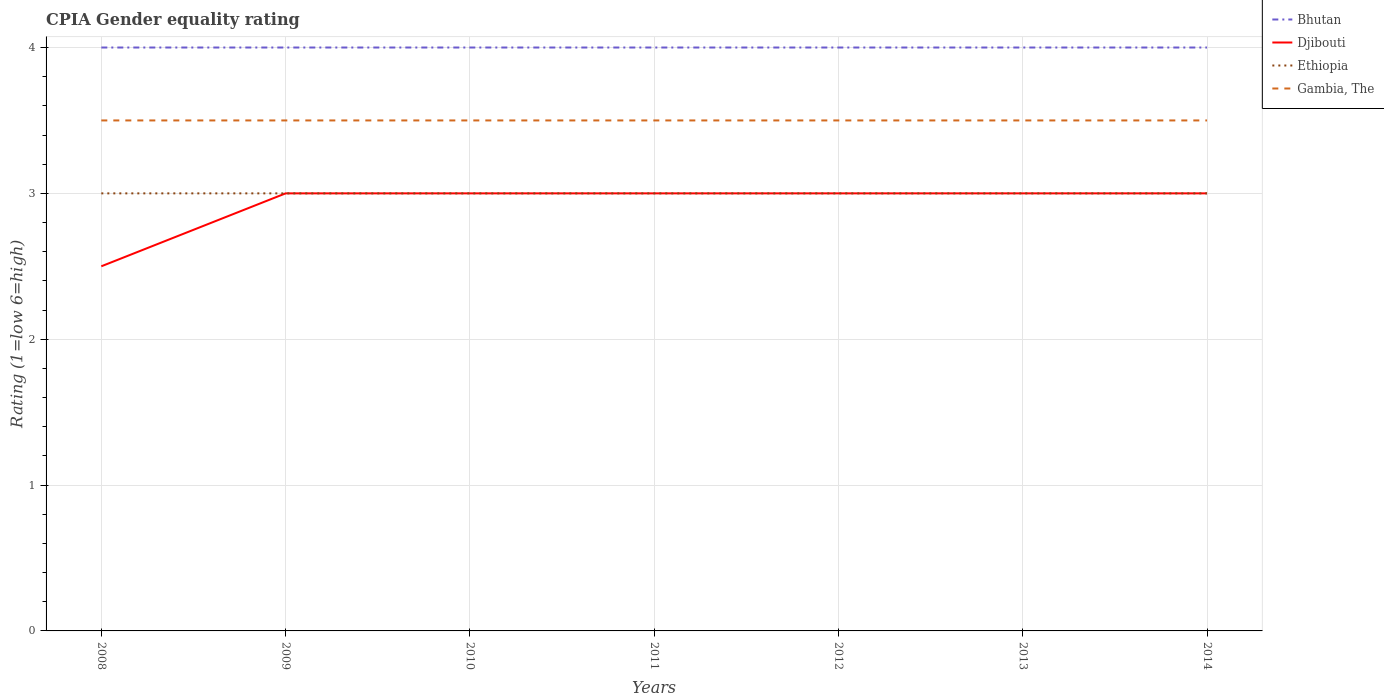How many different coloured lines are there?
Offer a terse response. 4. In which year was the CPIA rating in Bhutan maximum?
Offer a terse response. 2008. What is the difference between two consecutive major ticks on the Y-axis?
Ensure brevity in your answer.  1. Are the values on the major ticks of Y-axis written in scientific E-notation?
Offer a very short reply. No. Where does the legend appear in the graph?
Offer a terse response. Top right. How many legend labels are there?
Offer a very short reply. 4. What is the title of the graph?
Your answer should be compact. CPIA Gender equality rating. What is the label or title of the X-axis?
Your answer should be very brief. Years. What is the label or title of the Y-axis?
Make the answer very short. Rating (1=low 6=high). What is the Rating (1=low 6=high) of Bhutan in 2008?
Give a very brief answer. 4. What is the Rating (1=low 6=high) of Bhutan in 2009?
Offer a very short reply. 4. What is the Rating (1=low 6=high) in Ethiopia in 2009?
Make the answer very short. 3. What is the Rating (1=low 6=high) in Bhutan in 2010?
Your answer should be very brief. 4. What is the Rating (1=low 6=high) in Bhutan in 2011?
Provide a succinct answer. 4. What is the Rating (1=low 6=high) of Djibouti in 2011?
Provide a short and direct response. 3. What is the Rating (1=low 6=high) in Ethiopia in 2011?
Ensure brevity in your answer.  3. What is the Rating (1=low 6=high) in Djibouti in 2013?
Offer a terse response. 3. What is the Rating (1=low 6=high) in Ethiopia in 2013?
Your answer should be very brief. 3. What is the Rating (1=low 6=high) of Gambia, The in 2013?
Provide a short and direct response. 3.5. What is the Rating (1=low 6=high) of Bhutan in 2014?
Your answer should be very brief. 4. What is the Rating (1=low 6=high) in Ethiopia in 2014?
Provide a succinct answer. 3. Across all years, what is the maximum Rating (1=low 6=high) of Gambia, The?
Provide a short and direct response. 3.5. Across all years, what is the minimum Rating (1=low 6=high) in Bhutan?
Offer a very short reply. 4. Across all years, what is the minimum Rating (1=low 6=high) of Djibouti?
Your response must be concise. 2.5. What is the total Rating (1=low 6=high) of Bhutan in the graph?
Your answer should be compact. 28. What is the total Rating (1=low 6=high) of Djibouti in the graph?
Ensure brevity in your answer.  20.5. What is the total Rating (1=low 6=high) of Ethiopia in the graph?
Your answer should be very brief. 21. What is the total Rating (1=low 6=high) in Gambia, The in the graph?
Your answer should be compact. 24.5. What is the difference between the Rating (1=low 6=high) in Djibouti in 2008 and that in 2009?
Your response must be concise. -0.5. What is the difference between the Rating (1=low 6=high) of Ethiopia in 2008 and that in 2009?
Provide a succinct answer. 0. What is the difference between the Rating (1=low 6=high) of Bhutan in 2008 and that in 2010?
Ensure brevity in your answer.  0. What is the difference between the Rating (1=low 6=high) of Djibouti in 2008 and that in 2010?
Provide a short and direct response. -0.5. What is the difference between the Rating (1=low 6=high) in Gambia, The in 2008 and that in 2010?
Give a very brief answer. 0. What is the difference between the Rating (1=low 6=high) of Bhutan in 2008 and that in 2011?
Keep it short and to the point. 0. What is the difference between the Rating (1=low 6=high) of Djibouti in 2008 and that in 2011?
Keep it short and to the point. -0.5. What is the difference between the Rating (1=low 6=high) of Ethiopia in 2008 and that in 2011?
Make the answer very short. 0. What is the difference between the Rating (1=low 6=high) of Gambia, The in 2008 and that in 2011?
Offer a very short reply. 0. What is the difference between the Rating (1=low 6=high) of Ethiopia in 2008 and that in 2012?
Keep it short and to the point. 0. What is the difference between the Rating (1=low 6=high) of Gambia, The in 2008 and that in 2012?
Your answer should be compact. 0. What is the difference between the Rating (1=low 6=high) in Djibouti in 2008 and that in 2013?
Offer a terse response. -0.5. What is the difference between the Rating (1=low 6=high) of Ethiopia in 2008 and that in 2013?
Provide a short and direct response. 0. What is the difference between the Rating (1=low 6=high) of Bhutan in 2008 and that in 2014?
Provide a succinct answer. 0. What is the difference between the Rating (1=low 6=high) in Gambia, The in 2008 and that in 2014?
Ensure brevity in your answer.  0. What is the difference between the Rating (1=low 6=high) of Bhutan in 2009 and that in 2010?
Provide a succinct answer. 0. What is the difference between the Rating (1=low 6=high) of Ethiopia in 2009 and that in 2010?
Keep it short and to the point. 0. What is the difference between the Rating (1=low 6=high) in Gambia, The in 2009 and that in 2010?
Keep it short and to the point. 0. What is the difference between the Rating (1=low 6=high) in Bhutan in 2009 and that in 2011?
Provide a succinct answer. 0. What is the difference between the Rating (1=low 6=high) of Gambia, The in 2009 and that in 2011?
Make the answer very short. 0. What is the difference between the Rating (1=low 6=high) in Bhutan in 2009 and that in 2012?
Your answer should be compact. 0. What is the difference between the Rating (1=low 6=high) of Bhutan in 2009 and that in 2013?
Give a very brief answer. 0. What is the difference between the Rating (1=low 6=high) of Djibouti in 2009 and that in 2013?
Provide a succinct answer. 0. What is the difference between the Rating (1=low 6=high) in Gambia, The in 2009 and that in 2013?
Your answer should be very brief. 0. What is the difference between the Rating (1=low 6=high) of Ethiopia in 2009 and that in 2014?
Provide a succinct answer. 0. What is the difference between the Rating (1=low 6=high) in Djibouti in 2010 and that in 2011?
Provide a short and direct response. 0. What is the difference between the Rating (1=low 6=high) of Ethiopia in 2010 and that in 2011?
Make the answer very short. 0. What is the difference between the Rating (1=low 6=high) of Gambia, The in 2010 and that in 2011?
Provide a succinct answer. 0. What is the difference between the Rating (1=low 6=high) of Djibouti in 2010 and that in 2012?
Your answer should be compact. 0. What is the difference between the Rating (1=low 6=high) of Ethiopia in 2010 and that in 2012?
Your answer should be compact. 0. What is the difference between the Rating (1=low 6=high) in Gambia, The in 2010 and that in 2012?
Offer a terse response. 0. What is the difference between the Rating (1=low 6=high) in Bhutan in 2010 and that in 2013?
Keep it short and to the point. 0. What is the difference between the Rating (1=low 6=high) of Djibouti in 2010 and that in 2013?
Offer a very short reply. 0. What is the difference between the Rating (1=low 6=high) of Ethiopia in 2010 and that in 2013?
Your answer should be compact. 0. What is the difference between the Rating (1=low 6=high) of Gambia, The in 2010 and that in 2013?
Provide a short and direct response. 0. What is the difference between the Rating (1=low 6=high) of Djibouti in 2010 and that in 2014?
Your response must be concise. 0. What is the difference between the Rating (1=low 6=high) of Ethiopia in 2010 and that in 2014?
Keep it short and to the point. 0. What is the difference between the Rating (1=low 6=high) in Bhutan in 2011 and that in 2012?
Offer a terse response. 0. What is the difference between the Rating (1=low 6=high) in Ethiopia in 2011 and that in 2013?
Give a very brief answer. 0. What is the difference between the Rating (1=low 6=high) of Djibouti in 2011 and that in 2014?
Give a very brief answer. 0. What is the difference between the Rating (1=low 6=high) of Ethiopia in 2011 and that in 2014?
Make the answer very short. 0. What is the difference between the Rating (1=low 6=high) in Gambia, The in 2011 and that in 2014?
Ensure brevity in your answer.  0. What is the difference between the Rating (1=low 6=high) of Bhutan in 2012 and that in 2013?
Ensure brevity in your answer.  0. What is the difference between the Rating (1=low 6=high) in Gambia, The in 2012 and that in 2013?
Give a very brief answer. 0. What is the difference between the Rating (1=low 6=high) of Bhutan in 2012 and that in 2014?
Provide a short and direct response. 0. What is the difference between the Rating (1=low 6=high) of Gambia, The in 2012 and that in 2014?
Give a very brief answer. 0. What is the difference between the Rating (1=low 6=high) in Bhutan in 2013 and that in 2014?
Keep it short and to the point. 0. What is the difference between the Rating (1=low 6=high) in Djibouti in 2013 and that in 2014?
Give a very brief answer. 0. What is the difference between the Rating (1=low 6=high) of Bhutan in 2008 and the Rating (1=low 6=high) of Djibouti in 2009?
Make the answer very short. 1. What is the difference between the Rating (1=low 6=high) of Bhutan in 2008 and the Rating (1=low 6=high) of Ethiopia in 2009?
Give a very brief answer. 1. What is the difference between the Rating (1=low 6=high) of Bhutan in 2008 and the Rating (1=low 6=high) of Gambia, The in 2009?
Your response must be concise. 0.5. What is the difference between the Rating (1=low 6=high) of Ethiopia in 2008 and the Rating (1=low 6=high) of Gambia, The in 2009?
Offer a very short reply. -0.5. What is the difference between the Rating (1=low 6=high) of Bhutan in 2008 and the Rating (1=low 6=high) of Gambia, The in 2010?
Make the answer very short. 0.5. What is the difference between the Rating (1=low 6=high) in Djibouti in 2008 and the Rating (1=low 6=high) in Gambia, The in 2010?
Ensure brevity in your answer.  -1. What is the difference between the Rating (1=low 6=high) of Ethiopia in 2008 and the Rating (1=low 6=high) of Gambia, The in 2010?
Your answer should be compact. -0.5. What is the difference between the Rating (1=low 6=high) in Bhutan in 2008 and the Rating (1=low 6=high) in Djibouti in 2011?
Your answer should be very brief. 1. What is the difference between the Rating (1=low 6=high) in Bhutan in 2008 and the Rating (1=low 6=high) in Ethiopia in 2011?
Your response must be concise. 1. What is the difference between the Rating (1=low 6=high) of Djibouti in 2008 and the Rating (1=low 6=high) of Ethiopia in 2011?
Provide a short and direct response. -0.5. What is the difference between the Rating (1=low 6=high) of Bhutan in 2008 and the Rating (1=low 6=high) of Djibouti in 2012?
Your answer should be compact. 1. What is the difference between the Rating (1=low 6=high) of Bhutan in 2008 and the Rating (1=low 6=high) of Ethiopia in 2012?
Make the answer very short. 1. What is the difference between the Rating (1=low 6=high) in Djibouti in 2008 and the Rating (1=low 6=high) in Ethiopia in 2012?
Your answer should be very brief. -0.5. What is the difference between the Rating (1=low 6=high) in Djibouti in 2008 and the Rating (1=low 6=high) in Gambia, The in 2012?
Give a very brief answer. -1. What is the difference between the Rating (1=low 6=high) in Ethiopia in 2008 and the Rating (1=low 6=high) in Gambia, The in 2012?
Your answer should be very brief. -0.5. What is the difference between the Rating (1=low 6=high) in Bhutan in 2008 and the Rating (1=low 6=high) in Ethiopia in 2013?
Provide a short and direct response. 1. What is the difference between the Rating (1=low 6=high) in Djibouti in 2008 and the Rating (1=low 6=high) in Gambia, The in 2013?
Provide a succinct answer. -1. What is the difference between the Rating (1=low 6=high) in Ethiopia in 2008 and the Rating (1=low 6=high) in Gambia, The in 2013?
Keep it short and to the point. -0.5. What is the difference between the Rating (1=low 6=high) of Bhutan in 2008 and the Rating (1=low 6=high) of Ethiopia in 2014?
Your answer should be very brief. 1. What is the difference between the Rating (1=low 6=high) in Djibouti in 2008 and the Rating (1=low 6=high) in Ethiopia in 2014?
Make the answer very short. -0.5. What is the difference between the Rating (1=low 6=high) of Ethiopia in 2008 and the Rating (1=low 6=high) of Gambia, The in 2014?
Offer a very short reply. -0.5. What is the difference between the Rating (1=low 6=high) of Bhutan in 2009 and the Rating (1=low 6=high) of Gambia, The in 2010?
Make the answer very short. 0.5. What is the difference between the Rating (1=low 6=high) of Djibouti in 2009 and the Rating (1=low 6=high) of Gambia, The in 2010?
Provide a short and direct response. -0.5. What is the difference between the Rating (1=low 6=high) of Ethiopia in 2009 and the Rating (1=low 6=high) of Gambia, The in 2010?
Your answer should be very brief. -0.5. What is the difference between the Rating (1=low 6=high) of Bhutan in 2009 and the Rating (1=low 6=high) of Ethiopia in 2011?
Your answer should be compact. 1. What is the difference between the Rating (1=low 6=high) of Djibouti in 2009 and the Rating (1=low 6=high) of Gambia, The in 2011?
Your answer should be very brief. -0.5. What is the difference between the Rating (1=low 6=high) in Bhutan in 2009 and the Rating (1=low 6=high) in Ethiopia in 2012?
Your answer should be compact. 1. What is the difference between the Rating (1=low 6=high) in Ethiopia in 2009 and the Rating (1=low 6=high) in Gambia, The in 2012?
Offer a terse response. -0.5. What is the difference between the Rating (1=low 6=high) in Bhutan in 2009 and the Rating (1=low 6=high) in Djibouti in 2013?
Keep it short and to the point. 1. What is the difference between the Rating (1=low 6=high) in Bhutan in 2009 and the Rating (1=low 6=high) in Ethiopia in 2013?
Keep it short and to the point. 1. What is the difference between the Rating (1=low 6=high) in Bhutan in 2009 and the Rating (1=low 6=high) in Gambia, The in 2013?
Your answer should be compact. 0.5. What is the difference between the Rating (1=low 6=high) in Djibouti in 2009 and the Rating (1=low 6=high) in Gambia, The in 2013?
Offer a very short reply. -0.5. What is the difference between the Rating (1=low 6=high) of Ethiopia in 2009 and the Rating (1=low 6=high) of Gambia, The in 2013?
Offer a terse response. -0.5. What is the difference between the Rating (1=low 6=high) of Bhutan in 2009 and the Rating (1=low 6=high) of Djibouti in 2014?
Provide a short and direct response. 1. What is the difference between the Rating (1=low 6=high) of Bhutan in 2009 and the Rating (1=low 6=high) of Ethiopia in 2014?
Provide a short and direct response. 1. What is the difference between the Rating (1=low 6=high) of Bhutan in 2009 and the Rating (1=low 6=high) of Gambia, The in 2014?
Keep it short and to the point. 0.5. What is the difference between the Rating (1=low 6=high) of Ethiopia in 2010 and the Rating (1=low 6=high) of Gambia, The in 2011?
Your answer should be very brief. -0.5. What is the difference between the Rating (1=low 6=high) in Bhutan in 2010 and the Rating (1=low 6=high) in Ethiopia in 2012?
Offer a terse response. 1. What is the difference between the Rating (1=low 6=high) in Bhutan in 2010 and the Rating (1=low 6=high) in Gambia, The in 2012?
Your response must be concise. 0.5. What is the difference between the Rating (1=low 6=high) in Djibouti in 2010 and the Rating (1=low 6=high) in Gambia, The in 2012?
Offer a terse response. -0.5. What is the difference between the Rating (1=low 6=high) of Djibouti in 2010 and the Rating (1=low 6=high) of Ethiopia in 2013?
Give a very brief answer. 0. What is the difference between the Rating (1=low 6=high) of Djibouti in 2010 and the Rating (1=low 6=high) of Gambia, The in 2013?
Your response must be concise. -0.5. What is the difference between the Rating (1=low 6=high) in Bhutan in 2010 and the Rating (1=low 6=high) in Ethiopia in 2014?
Provide a succinct answer. 1. What is the difference between the Rating (1=low 6=high) in Bhutan in 2010 and the Rating (1=low 6=high) in Gambia, The in 2014?
Provide a short and direct response. 0.5. What is the difference between the Rating (1=low 6=high) of Djibouti in 2010 and the Rating (1=low 6=high) of Ethiopia in 2014?
Offer a very short reply. 0. What is the difference between the Rating (1=low 6=high) in Ethiopia in 2010 and the Rating (1=low 6=high) in Gambia, The in 2014?
Keep it short and to the point. -0.5. What is the difference between the Rating (1=low 6=high) in Bhutan in 2011 and the Rating (1=low 6=high) in Djibouti in 2012?
Make the answer very short. 1. What is the difference between the Rating (1=low 6=high) of Bhutan in 2011 and the Rating (1=low 6=high) of Ethiopia in 2012?
Your answer should be very brief. 1. What is the difference between the Rating (1=low 6=high) of Bhutan in 2011 and the Rating (1=low 6=high) of Gambia, The in 2012?
Offer a terse response. 0.5. What is the difference between the Rating (1=low 6=high) of Djibouti in 2011 and the Rating (1=low 6=high) of Gambia, The in 2012?
Ensure brevity in your answer.  -0.5. What is the difference between the Rating (1=low 6=high) of Ethiopia in 2011 and the Rating (1=low 6=high) of Gambia, The in 2012?
Keep it short and to the point. -0.5. What is the difference between the Rating (1=low 6=high) in Bhutan in 2011 and the Rating (1=low 6=high) in Djibouti in 2013?
Give a very brief answer. 1. What is the difference between the Rating (1=low 6=high) in Bhutan in 2011 and the Rating (1=low 6=high) in Ethiopia in 2013?
Give a very brief answer. 1. What is the difference between the Rating (1=low 6=high) of Djibouti in 2011 and the Rating (1=low 6=high) of Ethiopia in 2013?
Provide a succinct answer. 0. What is the difference between the Rating (1=low 6=high) in Djibouti in 2011 and the Rating (1=low 6=high) in Gambia, The in 2013?
Offer a terse response. -0.5. What is the difference between the Rating (1=low 6=high) of Djibouti in 2011 and the Rating (1=low 6=high) of Gambia, The in 2014?
Your answer should be compact. -0.5. What is the difference between the Rating (1=low 6=high) in Bhutan in 2012 and the Rating (1=low 6=high) in Djibouti in 2013?
Keep it short and to the point. 1. What is the difference between the Rating (1=low 6=high) of Djibouti in 2012 and the Rating (1=low 6=high) of Ethiopia in 2013?
Provide a short and direct response. 0. What is the difference between the Rating (1=low 6=high) of Ethiopia in 2012 and the Rating (1=low 6=high) of Gambia, The in 2013?
Keep it short and to the point. -0.5. What is the difference between the Rating (1=low 6=high) of Djibouti in 2012 and the Rating (1=low 6=high) of Gambia, The in 2014?
Provide a succinct answer. -0.5. What is the difference between the Rating (1=low 6=high) in Ethiopia in 2012 and the Rating (1=low 6=high) in Gambia, The in 2014?
Offer a terse response. -0.5. What is the difference between the Rating (1=low 6=high) of Bhutan in 2013 and the Rating (1=low 6=high) of Djibouti in 2014?
Keep it short and to the point. 1. What is the difference between the Rating (1=low 6=high) of Bhutan in 2013 and the Rating (1=low 6=high) of Ethiopia in 2014?
Give a very brief answer. 1. What is the difference between the Rating (1=low 6=high) in Djibouti in 2013 and the Rating (1=low 6=high) in Gambia, The in 2014?
Provide a short and direct response. -0.5. What is the average Rating (1=low 6=high) of Djibouti per year?
Keep it short and to the point. 2.93. What is the average Rating (1=low 6=high) in Gambia, The per year?
Keep it short and to the point. 3.5. In the year 2008, what is the difference between the Rating (1=low 6=high) of Bhutan and Rating (1=low 6=high) of Gambia, The?
Your answer should be very brief. 0.5. In the year 2008, what is the difference between the Rating (1=low 6=high) of Djibouti and Rating (1=low 6=high) of Ethiopia?
Offer a very short reply. -0.5. In the year 2008, what is the difference between the Rating (1=low 6=high) in Djibouti and Rating (1=low 6=high) in Gambia, The?
Keep it short and to the point. -1. In the year 2009, what is the difference between the Rating (1=low 6=high) in Bhutan and Rating (1=low 6=high) in Djibouti?
Offer a terse response. 1. In the year 2009, what is the difference between the Rating (1=low 6=high) of Bhutan and Rating (1=low 6=high) of Ethiopia?
Offer a terse response. 1. In the year 2009, what is the difference between the Rating (1=low 6=high) of Bhutan and Rating (1=low 6=high) of Gambia, The?
Make the answer very short. 0.5. In the year 2011, what is the difference between the Rating (1=low 6=high) of Bhutan and Rating (1=low 6=high) of Ethiopia?
Keep it short and to the point. 1. In the year 2011, what is the difference between the Rating (1=low 6=high) of Djibouti and Rating (1=low 6=high) of Ethiopia?
Keep it short and to the point. 0. In the year 2011, what is the difference between the Rating (1=low 6=high) in Djibouti and Rating (1=low 6=high) in Gambia, The?
Provide a short and direct response. -0.5. In the year 2012, what is the difference between the Rating (1=low 6=high) of Bhutan and Rating (1=low 6=high) of Djibouti?
Your response must be concise. 1. In the year 2012, what is the difference between the Rating (1=low 6=high) of Djibouti and Rating (1=low 6=high) of Ethiopia?
Provide a short and direct response. 0. In the year 2012, what is the difference between the Rating (1=low 6=high) of Djibouti and Rating (1=low 6=high) of Gambia, The?
Provide a succinct answer. -0.5. In the year 2012, what is the difference between the Rating (1=low 6=high) in Ethiopia and Rating (1=low 6=high) in Gambia, The?
Offer a very short reply. -0.5. In the year 2013, what is the difference between the Rating (1=low 6=high) of Bhutan and Rating (1=low 6=high) of Djibouti?
Give a very brief answer. 1. In the year 2013, what is the difference between the Rating (1=low 6=high) of Bhutan and Rating (1=low 6=high) of Ethiopia?
Your answer should be compact. 1. In the year 2013, what is the difference between the Rating (1=low 6=high) in Djibouti and Rating (1=low 6=high) in Ethiopia?
Provide a succinct answer. 0. In the year 2013, what is the difference between the Rating (1=low 6=high) in Ethiopia and Rating (1=low 6=high) in Gambia, The?
Offer a terse response. -0.5. In the year 2014, what is the difference between the Rating (1=low 6=high) in Bhutan and Rating (1=low 6=high) in Ethiopia?
Your answer should be compact. 1. In the year 2014, what is the difference between the Rating (1=low 6=high) of Djibouti and Rating (1=low 6=high) of Ethiopia?
Offer a very short reply. 0. What is the ratio of the Rating (1=low 6=high) in Djibouti in 2008 to that in 2009?
Provide a succinct answer. 0.83. What is the ratio of the Rating (1=low 6=high) of Ethiopia in 2008 to that in 2010?
Give a very brief answer. 1. What is the ratio of the Rating (1=low 6=high) in Bhutan in 2008 to that in 2011?
Provide a short and direct response. 1. What is the ratio of the Rating (1=low 6=high) in Gambia, The in 2008 to that in 2011?
Offer a very short reply. 1. What is the ratio of the Rating (1=low 6=high) of Djibouti in 2008 to that in 2012?
Keep it short and to the point. 0.83. What is the ratio of the Rating (1=low 6=high) in Ethiopia in 2008 to that in 2012?
Keep it short and to the point. 1. What is the ratio of the Rating (1=low 6=high) in Ethiopia in 2008 to that in 2013?
Give a very brief answer. 1. What is the ratio of the Rating (1=low 6=high) in Gambia, The in 2008 to that in 2013?
Give a very brief answer. 1. What is the ratio of the Rating (1=low 6=high) in Bhutan in 2008 to that in 2014?
Your response must be concise. 1. What is the ratio of the Rating (1=low 6=high) in Djibouti in 2008 to that in 2014?
Make the answer very short. 0.83. What is the ratio of the Rating (1=low 6=high) of Ethiopia in 2008 to that in 2014?
Provide a succinct answer. 1. What is the ratio of the Rating (1=low 6=high) in Gambia, The in 2008 to that in 2014?
Keep it short and to the point. 1. What is the ratio of the Rating (1=low 6=high) of Bhutan in 2009 to that in 2010?
Provide a succinct answer. 1. What is the ratio of the Rating (1=low 6=high) in Djibouti in 2009 to that in 2010?
Make the answer very short. 1. What is the ratio of the Rating (1=low 6=high) of Gambia, The in 2009 to that in 2010?
Offer a very short reply. 1. What is the ratio of the Rating (1=low 6=high) in Bhutan in 2009 to that in 2011?
Give a very brief answer. 1. What is the ratio of the Rating (1=low 6=high) of Djibouti in 2009 to that in 2011?
Your answer should be compact. 1. What is the ratio of the Rating (1=low 6=high) of Gambia, The in 2009 to that in 2011?
Offer a very short reply. 1. What is the ratio of the Rating (1=low 6=high) in Bhutan in 2009 to that in 2012?
Keep it short and to the point. 1. What is the ratio of the Rating (1=low 6=high) in Djibouti in 2009 to that in 2012?
Make the answer very short. 1. What is the ratio of the Rating (1=low 6=high) of Djibouti in 2009 to that in 2013?
Give a very brief answer. 1. What is the ratio of the Rating (1=low 6=high) in Ethiopia in 2009 to that in 2013?
Your response must be concise. 1. What is the ratio of the Rating (1=low 6=high) of Gambia, The in 2009 to that in 2013?
Ensure brevity in your answer.  1. What is the ratio of the Rating (1=low 6=high) in Bhutan in 2010 to that in 2011?
Your answer should be very brief. 1. What is the ratio of the Rating (1=low 6=high) of Djibouti in 2010 to that in 2011?
Provide a succinct answer. 1. What is the ratio of the Rating (1=low 6=high) in Gambia, The in 2010 to that in 2011?
Provide a short and direct response. 1. What is the ratio of the Rating (1=low 6=high) of Djibouti in 2010 to that in 2012?
Make the answer very short. 1. What is the ratio of the Rating (1=low 6=high) of Ethiopia in 2010 to that in 2012?
Offer a very short reply. 1. What is the ratio of the Rating (1=low 6=high) of Bhutan in 2010 to that in 2013?
Keep it short and to the point. 1. What is the ratio of the Rating (1=low 6=high) of Djibouti in 2010 to that in 2013?
Your response must be concise. 1. What is the ratio of the Rating (1=low 6=high) of Ethiopia in 2010 to that in 2013?
Offer a terse response. 1. What is the ratio of the Rating (1=low 6=high) of Gambia, The in 2010 to that in 2013?
Offer a very short reply. 1. What is the ratio of the Rating (1=low 6=high) in Gambia, The in 2010 to that in 2014?
Your answer should be compact. 1. What is the ratio of the Rating (1=low 6=high) in Djibouti in 2011 to that in 2014?
Provide a succinct answer. 1. What is the ratio of the Rating (1=low 6=high) of Ethiopia in 2011 to that in 2014?
Provide a succinct answer. 1. What is the ratio of the Rating (1=low 6=high) in Gambia, The in 2011 to that in 2014?
Provide a short and direct response. 1. What is the ratio of the Rating (1=low 6=high) of Bhutan in 2012 to that in 2013?
Provide a short and direct response. 1. What is the ratio of the Rating (1=low 6=high) in Djibouti in 2012 to that in 2013?
Ensure brevity in your answer.  1. What is the ratio of the Rating (1=low 6=high) in Ethiopia in 2012 to that in 2013?
Offer a terse response. 1. What is the ratio of the Rating (1=low 6=high) in Bhutan in 2012 to that in 2014?
Offer a terse response. 1. What is the ratio of the Rating (1=low 6=high) of Ethiopia in 2012 to that in 2014?
Keep it short and to the point. 1. What is the ratio of the Rating (1=low 6=high) in Bhutan in 2013 to that in 2014?
Offer a very short reply. 1. What is the ratio of the Rating (1=low 6=high) in Djibouti in 2013 to that in 2014?
Make the answer very short. 1. What is the ratio of the Rating (1=low 6=high) of Ethiopia in 2013 to that in 2014?
Offer a very short reply. 1. What is the ratio of the Rating (1=low 6=high) in Gambia, The in 2013 to that in 2014?
Your answer should be compact. 1. What is the difference between the highest and the second highest Rating (1=low 6=high) in Bhutan?
Your answer should be compact. 0. What is the difference between the highest and the second highest Rating (1=low 6=high) in Ethiopia?
Your answer should be compact. 0. What is the difference between the highest and the second highest Rating (1=low 6=high) of Gambia, The?
Offer a terse response. 0. What is the difference between the highest and the lowest Rating (1=low 6=high) in Djibouti?
Your answer should be compact. 0.5. What is the difference between the highest and the lowest Rating (1=low 6=high) of Gambia, The?
Your answer should be compact. 0. 